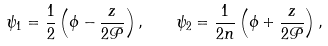Convert formula to latex. <formula><loc_0><loc_0><loc_500><loc_500>\psi _ { 1 } = \frac { 1 } { 2 } \left ( \phi - \frac { z } { 2 \mathcal { P } } \right ) , \quad \psi _ { 2 } = \frac { 1 } { 2 n } \left ( \phi + \frac { z } { 2 \mathcal { P } } \right ) ,</formula> 